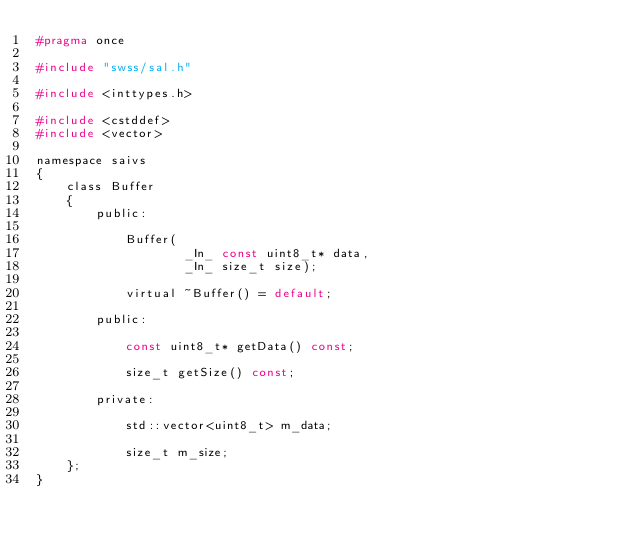<code> <loc_0><loc_0><loc_500><loc_500><_C_>#pragma once

#include "swss/sal.h"

#include <inttypes.h>

#include <cstddef>
#include <vector>

namespace saivs
{
    class Buffer
    {
        public:

            Buffer(
                    _In_ const uint8_t* data,
                    _In_ size_t size);

            virtual ~Buffer() = default;

        public:

            const uint8_t* getData() const;

            size_t getSize() const;

        private:

            std::vector<uint8_t> m_data;

            size_t m_size;
    };
}
</code> 